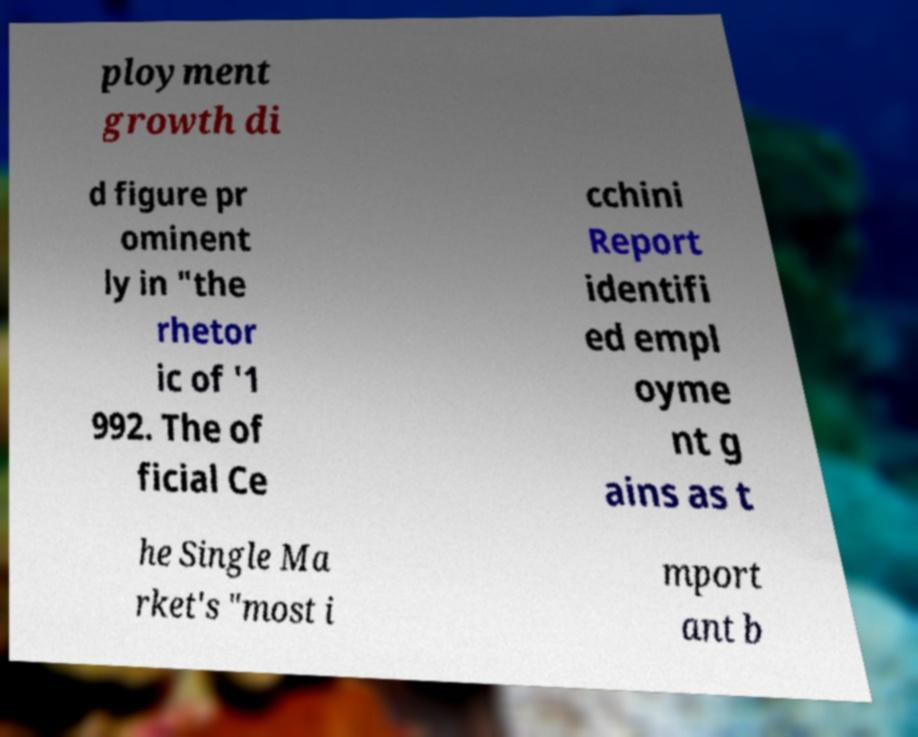What messages or text are displayed in this image? I need them in a readable, typed format. ployment growth di d figure pr ominent ly in "the rhetor ic of '1 992. The of ficial Ce cchini Report identifi ed empl oyme nt g ains as t he Single Ma rket's "most i mport ant b 